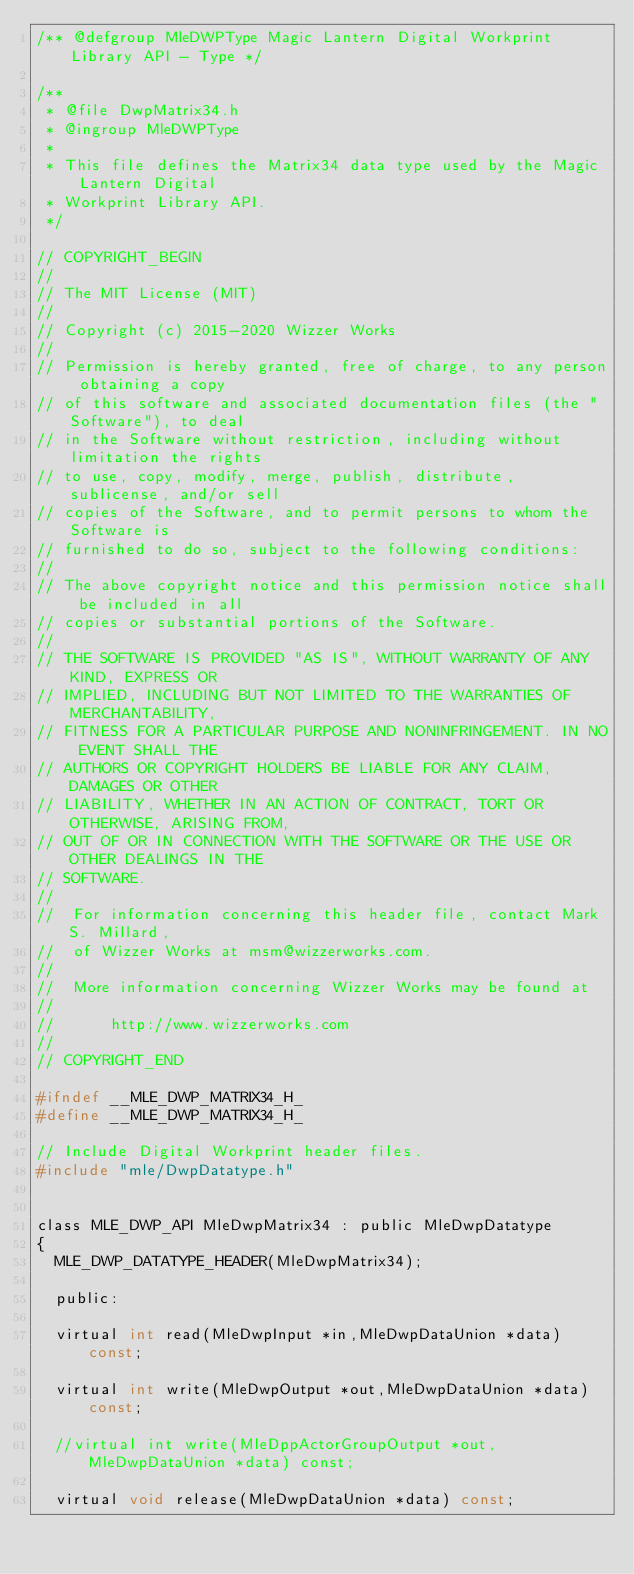<code> <loc_0><loc_0><loc_500><loc_500><_C_>/** @defgroup MleDWPType Magic Lantern Digital Workprint Library API - Type */

/**
 * @file DwpMatrix34.h
 * @ingroup MleDWPType
 *
 * This file defines the Matrix34 data type used by the Magic Lantern Digital
 * Workprint Library API.
 */

// COPYRIGHT_BEGIN
//
// The MIT License (MIT)
//
// Copyright (c) 2015-2020 Wizzer Works
//
// Permission is hereby granted, free of charge, to any person obtaining a copy
// of this software and associated documentation files (the "Software"), to deal
// in the Software without restriction, including without limitation the rights
// to use, copy, modify, merge, publish, distribute, sublicense, and/or sell
// copies of the Software, and to permit persons to whom the Software is
// furnished to do so, subject to the following conditions:
//
// The above copyright notice and this permission notice shall be included in all
// copies or substantial portions of the Software.
//
// THE SOFTWARE IS PROVIDED "AS IS", WITHOUT WARRANTY OF ANY KIND, EXPRESS OR
// IMPLIED, INCLUDING BUT NOT LIMITED TO THE WARRANTIES OF MERCHANTABILITY,
// FITNESS FOR A PARTICULAR PURPOSE AND NONINFRINGEMENT. IN NO EVENT SHALL THE
// AUTHORS OR COPYRIGHT HOLDERS BE LIABLE FOR ANY CLAIM, DAMAGES OR OTHER
// LIABILITY, WHETHER IN AN ACTION OF CONTRACT, TORT OR OTHERWISE, ARISING FROM,
// OUT OF OR IN CONNECTION WITH THE SOFTWARE OR THE USE OR OTHER DEALINGS IN THE
// SOFTWARE.
//
//  For information concerning this header file, contact Mark S. Millard,
//  of Wizzer Works at msm@wizzerworks.com.
//
//  More information concerning Wizzer Works may be found at
//
//      http://www.wizzerworks.com
//
// COPYRIGHT_END

#ifndef __MLE_DWP_MATRIX34_H_
#define __MLE_DWP_MATRIX34_H_

// Include Digital Workprint header files.
#include "mle/DwpDatatype.h"


class MLE_DWP_API MleDwpMatrix34 : public MleDwpDatatype
{
	MLE_DWP_DATATYPE_HEADER(MleDwpMatrix34);

  public:

	virtual int read(MleDwpInput *in,MleDwpDataUnion *data) const;

	virtual int write(MleDwpOutput *out,MleDwpDataUnion *data) const;

	//virtual int write(MleDppActorGroupOutput *out,MleDwpDataUnion *data) const;

	virtual void release(MleDwpDataUnion *data) const;
</code> 